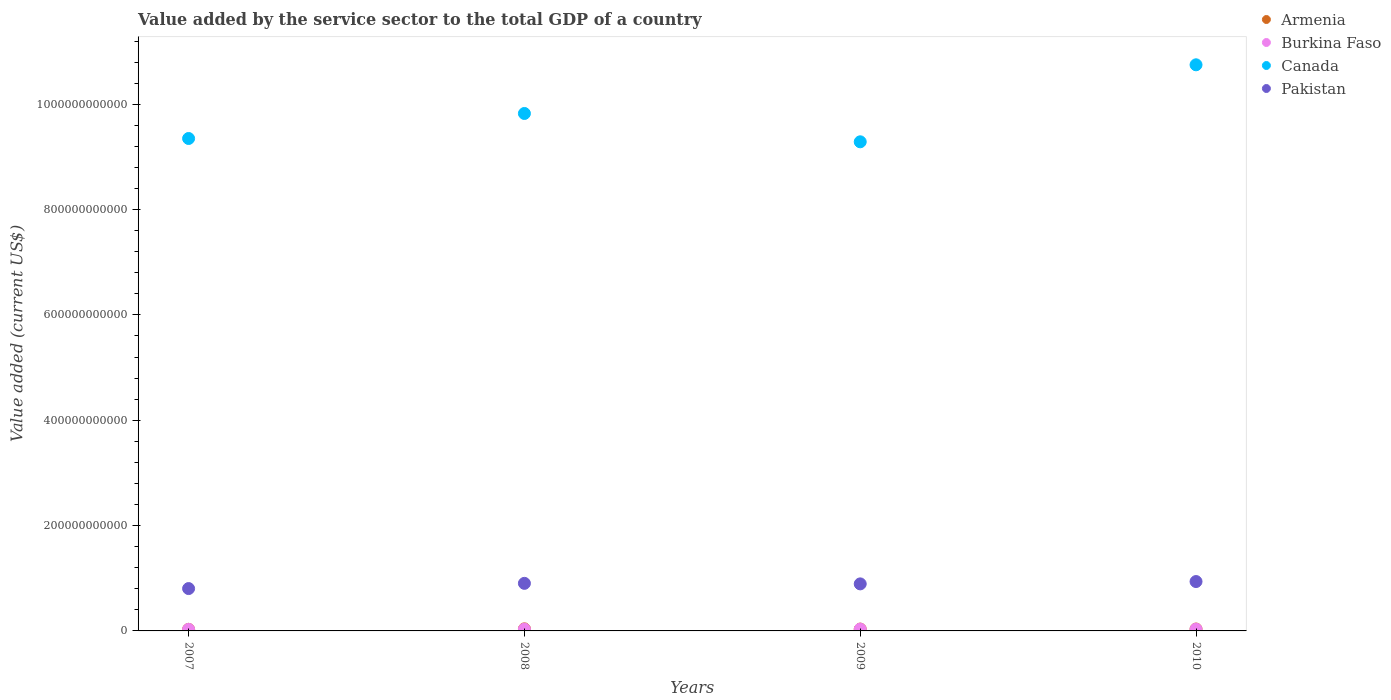How many different coloured dotlines are there?
Offer a terse response. 4. What is the value added by the service sector to the total GDP in Burkina Faso in 2009?
Your answer should be very brief. 3.44e+09. Across all years, what is the maximum value added by the service sector to the total GDP in Canada?
Provide a short and direct response. 1.07e+12. Across all years, what is the minimum value added by the service sector to the total GDP in Canada?
Ensure brevity in your answer.  9.29e+11. In which year was the value added by the service sector to the total GDP in Canada maximum?
Ensure brevity in your answer.  2010. In which year was the value added by the service sector to the total GDP in Canada minimum?
Offer a very short reply. 2009. What is the total value added by the service sector to the total GDP in Burkina Faso in the graph?
Provide a short and direct response. 1.32e+1. What is the difference between the value added by the service sector to the total GDP in Pakistan in 2007 and that in 2010?
Provide a short and direct response. -1.33e+1. What is the difference between the value added by the service sector to the total GDP in Armenia in 2007 and the value added by the service sector to the total GDP in Pakistan in 2010?
Ensure brevity in your answer.  -9.08e+1. What is the average value added by the service sector to the total GDP in Canada per year?
Make the answer very short. 9.80e+11. In the year 2007, what is the difference between the value added by the service sector to the total GDP in Armenia and value added by the service sector to the total GDP in Pakistan?
Offer a very short reply. -7.74e+1. In how many years, is the value added by the service sector to the total GDP in Pakistan greater than 800000000000 US$?
Provide a succinct answer. 0. What is the ratio of the value added by the service sector to the total GDP in Canada in 2007 to that in 2008?
Offer a terse response. 0.95. Is the value added by the service sector to the total GDP in Armenia in 2007 less than that in 2010?
Keep it short and to the point. Yes. What is the difference between the highest and the second highest value added by the service sector to the total GDP in Armenia?
Ensure brevity in your answer.  3.33e+08. What is the difference between the highest and the lowest value added by the service sector to the total GDP in Pakistan?
Provide a short and direct response. 1.33e+1. In how many years, is the value added by the service sector to the total GDP in Armenia greater than the average value added by the service sector to the total GDP in Armenia taken over all years?
Offer a very short reply. 3. Is it the case that in every year, the sum of the value added by the service sector to the total GDP in Burkina Faso and value added by the service sector to the total GDP in Armenia  is greater than the sum of value added by the service sector to the total GDP in Canada and value added by the service sector to the total GDP in Pakistan?
Your response must be concise. No. Is it the case that in every year, the sum of the value added by the service sector to the total GDP in Canada and value added by the service sector to the total GDP in Armenia  is greater than the value added by the service sector to the total GDP in Pakistan?
Keep it short and to the point. Yes. Does the value added by the service sector to the total GDP in Pakistan monotonically increase over the years?
Ensure brevity in your answer.  No. What is the difference between two consecutive major ticks on the Y-axis?
Your answer should be very brief. 2.00e+11. Where does the legend appear in the graph?
Ensure brevity in your answer.  Top right. What is the title of the graph?
Ensure brevity in your answer.  Value added by the service sector to the total GDP of a country. What is the label or title of the X-axis?
Make the answer very short. Years. What is the label or title of the Y-axis?
Give a very brief answer. Value added (current US$). What is the Value added (current US$) in Armenia in 2007?
Your answer should be compact. 2.97e+09. What is the Value added (current US$) in Burkina Faso in 2007?
Offer a very short reply. 3.00e+09. What is the Value added (current US$) of Canada in 2007?
Your answer should be very brief. 9.35e+11. What is the Value added (current US$) in Pakistan in 2007?
Keep it short and to the point. 8.04e+1. What is the Value added (current US$) of Armenia in 2008?
Offer a terse response. 3.93e+09. What is the Value added (current US$) of Burkina Faso in 2008?
Provide a succinct answer. 3.36e+09. What is the Value added (current US$) of Canada in 2008?
Your response must be concise. 9.82e+11. What is the Value added (current US$) of Pakistan in 2008?
Provide a short and direct response. 9.03e+1. What is the Value added (current US$) in Armenia in 2009?
Offer a terse response. 3.50e+09. What is the Value added (current US$) of Burkina Faso in 2009?
Make the answer very short. 3.44e+09. What is the Value added (current US$) of Canada in 2009?
Your response must be concise. 9.29e+11. What is the Value added (current US$) of Pakistan in 2009?
Offer a terse response. 8.93e+1. What is the Value added (current US$) in Armenia in 2010?
Your response must be concise. 3.60e+09. What is the Value added (current US$) of Burkina Faso in 2010?
Provide a short and direct response. 3.39e+09. What is the Value added (current US$) of Canada in 2010?
Give a very brief answer. 1.07e+12. What is the Value added (current US$) of Pakistan in 2010?
Give a very brief answer. 9.37e+1. Across all years, what is the maximum Value added (current US$) in Armenia?
Your answer should be compact. 3.93e+09. Across all years, what is the maximum Value added (current US$) in Burkina Faso?
Provide a short and direct response. 3.44e+09. Across all years, what is the maximum Value added (current US$) of Canada?
Give a very brief answer. 1.07e+12. Across all years, what is the maximum Value added (current US$) of Pakistan?
Offer a terse response. 9.37e+1. Across all years, what is the minimum Value added (current US$) of Armenia?
Offer a terse response. 2.97e+09. Across all years, what is the minimum Value added (current US$) in Burkina Faso?
Give a very brief answer. 3.00e+09. Across all years, what is the minimum Value added (current US$) in Canada?
Your answer should be compact. 9.29e+11. Across all years, what is the minimum Value added (current US$) of Pakistan?
Keep it short and to the point. 8.04e+1. What is the total Value added (current US$) of Armenia in the graph?
Ensure brevity in your answer.  1.40e+1. What is the total Value added (current US$) of Burkina Faso in the graph?
Make the answer very short. 1.32e+1. What is the total Value added (current US$) of Canada in the graph?
Keep it short and to the point. 3.92e+12. What is the total Value added (current US$) of Pakistan in the graph?
Make the answer very short. 3.54e+11. What is the difference between the Value added (current US$) of Armenia in 2007 and that in 2008?
Your answer should be compact. -9.67e+08. What is the difference between the Value added (current US$) of Burkina Faso in 2007 and that in 2008?
Offer a very short reply. -3.55e+08. What is the difference between the Value added (current US$) of Canada in 2007 and that in 2008?
Your answer should be compact. -4.75e+1. What is the difference between the Value added (current US$) in Pakistan in 2007 and that in 2008?
Your answer should be compact. -9.92e+09. What is the difference between the Value added (current US$) in Armenia in 2007 and that in 2009?
Give a very brief answer. -5.35e+08. What is the difference between the Value added (current US$) in Burkina Faso in 2007 and that in 2009?
Make the answer very short. -4.35e+08. What is the difference between the Value added (current US$) of Canada in 2007 and that in 2009?
Keep it short and to the point. 6.28e+09. What is the difference between the Value added (current US$) in Pakistan in 2007 and that in 2009?
Make the answer very short. -8.90e+09. What is the difference between the Value added (current US$) in Armenia in 2007 and that in 2010?
Ensure brevity in your answer.  -6.35e+08. What is the difference between the Value added (current US$) of Burkina Faso in 2007 and that in 2010?
Offer a very short reply. -3.93e+08. What is the difference between the Value added (current US$) in Canada in 2007 and that in 2010?
Your answer should be very brief. -1.40e+11. What is the difference between the Value added (current US$) of Pakistan in 2007 and that in 2010?
Your answer should be compact. -1.33e+1. What is the difference between the Value added (current US$) in Armenia in 2008 and that in 2009?
Make the answer very short. 4.33e+08. What is the difference between the Value added (current US$) of Burkina Faso in 2008 and that in 2009?
Provide a succinct answer. -7.99e+07. What is the difference between the Value added (current US$) in Canada in 2008 and that in 2009?
Make the answer very short. 5.38e+1. What is the difference between the Value added (current US$) in Pakistan in 2008 and that in 2009?
Give a very brief answer. 1.02e+09. What is the difference between the Value added (current US$) in Armenia in 2008 and that in 2010?
Your response must be concise. 3.33e+08. What is the difference between the Value added (current US$) of Burkina Faso in 2008 and that in 2010?
Give a very brief answer. -3.77e+07. What is the difference between the Value added (current US$) of Canada in 2008 and that in 2010?
Provide a succinct answer. -9.24e+1. What is the difference between the Value added (current US$) of Pakistan in 2008 and that in 2010?
Make the answer very short. -3.42e+09. What is the difference between the Value added (current US$) in Armenia in 2009 and that in 2010?
Provide a short and direct response. -9.99e+07. What is the difference between the Value added (current US$) of Burkina Faso in 2009 and that in 2010?
Your response must be concise. 4.22e+07. What is the difference between the Value added (current US$) in Canada in 2009 and that in 2010?
Ensure brevity in your answer.  -1.46e+11. What is the difference between the Value added (current US$) in Pakistan in 2009 and that in 2010?
Give a very brief answer. -4.43e+09. What is the difference between the Value added (current US$) in Armenia in 2007 and the Value added (current US$) in Burkina Faso in 2008?
Offer a very short reply. -3.91e+08. What is the difference between the Value added (current US$) of Armenia in 2007 and the Value added (current US$) of Canada in 2008?
Your response must be concise. -9.79e+11. What is the difference between the Value added (current US$) in Armenia in 2007 and the Value added (current US$) in Pakistan in 2008?
Give a very brief answer. -8.74e+1. What is the difference between the Value added (current US$) in Burkina Faso in 2007 and the Value added (current US$) in Canada in 2008?
Provide a succinct answer. -9.79e+11. What is the difference between the Value added (current US$) of Burkina Faso in 2007 and the Value added (current US$) of Pakistan in 2008?
Your response must be concise. -8.73e+1. What is the difference between the Value added (current US$) in Canada in 2007 and the Value added (current US$) in Pakistan in 2008?
Give a very brief answer. 8.45e+11. What is the difference between the Value added (current US$) of Armenia in 2007 and the Value added (current US$) of Burkina Faso in 2009?
Your response must be concise. -4.71e+08. What is the difference between the Value added (current US$) of Armenia in 2007 and the Value added (current US$) of Canada in 2009?
Your answer should be very brief. -9.26e+11. What is the difference between the Value added (current US$) of Armenia in 2007 and the Value added (current US$) of Pakistan in 2009?
Your answer should be compact. -8.63e+1. What is the difference between the Value added (current US$) in Burkina Faso in 2007 and the Value added (current US$) in Canada in 2009?
Your answer should be compact. -9.26e+11. What is the difference between the Value added (current US$) of Burkina Faso in 2007 and the Value added (current US$) of Pakistan in 2009?
Provide a succinct answer. -8.63e+1. What is the difference between the Value added (current US$) in Canada in 2007 and the Value added (current US$) in Pakistan in 2009?
Your answer should be compact. 8.46e+11. What is the difference between the Value added (current US$) of Armenia in 2007 and the Value added (current US$) of Burkina Faso in 2010?
Offer a very short reply. -4.29e+08. What is the difference between the Value added (current US$) of Armenia in 2007 and the Value added (current US$) of Canada in 2010?
Give a very brief answer. -1.07e+12. What is the difference between the Value added (current US$) of Armenia in 2007 and the Value added (current US$) of Pakistan in 2010?
Your response must be concise. -9.08e+1. What is the difference between the Value added (current US$) of Burkina Faso in 2007 and the Value added (current US$) of Canada in 2010?
Ensure brevity in your answer.  -1.07e+12. What is the difference between the Value added (current US$) of Burkina Faso in 2007 and the Value added (current US$) of Pakistan in 2010?
Ensure brevity in your answer.  -9.07e+1. What is the difference between the Value added (current US$) in Canada in 2007 and the Value added (current US$) in Pakistan in 2010?
Your response must be concise. 8.41e+11. What is the difference between the Value added (current US$) in Armenia in 2008 and the Value added (current US$) in Burkina Faso in 2009?
Offer a terse response. 4.97e+08. What is the difference between the Value added (current US$) of Armenia in 2008 and the Value added (current US$) of Canada in 2009?
Give a very brief answer. -9.25e+11. What is the difference between the Value added (current US$) in Armenia in 2008 and the Value added (current US$) in Pakistan in 2009?
Your answer should be compact. -8.54e+1. What is the difference between the Value added (current US$) of Burkina Faso in 2008 and the Value added (current US$) of Canada in 2009?
Your response must be concise. -9.25e+11. What is the difference between the Value added (current US$) of Burkina Faso in 2008 and the Value added (current US$) of Pakistan in 2009?
Offer a terse response. -8.59e+1. What is the difference between the Value added (current US$) in Canada in 2008 and the Value added (current US$) in Pakistan in 2009?
Offer a very short reply. 8.93e+11. What is the difference between the Value added (current US$) in Armenia in 2008 and the Value added (current US$) in Burkina Faso in 2010?
Your answer should be very brief. 5.39e+08. What is the difference between the Value added (current US$) in Armenia in 2008 and the Value added (current US$) in Canada in 2010?
Make the answer very short. -1.07e+12. What is the difference between the Value added (current US$) in Armenia in 2008 and the Value added (current US$) in Pakistan in 2010?
Give a very brief answer. -8.98e+1. What is the difference between the Value added (current US$) in Burkina Faso in 2008 and the Value added (current US$) in Canada in 2010?
Your answer should be compact. -1.07e+12. What is the difference between the Value added (current US$) in Burkina Faso in 2008 and the Value added (current US$) in Pakistan in 2010?
Your response must be concise. -9.04e+1. What is the difference between the Value added (current US$) in Canada in 2008 and the Value added (current US$) in Pakistan in 2010?
Your answer should be very brief. 8.89e+11. What is the difference between the Value added (current US$) of Armenia in 2009 and the Value added (current US$) of Burkina Faso in 2010?
Make the answer very short. 1.06e+08. What is the difference between the Value added (current US$) of Armenia in 2009 and the Value added (current US$) of Canada in 2010?
Your answer should be very brief. -1.07e+12. What is the difference between the Value added (current US$) of Armenia in 2009 and the Value added (current US$) of Pakistan in 2010?
Provide a succinct answer. -9.02e+1. What is the difference between the Value added (current US$) of Burkina Faso in 2009 and the Value added (current US$) of Canada in 2010?
Offer a very short reply. -1.07e+12. What is the difference between the Value added (current US$) in Burkina Faso in 2009 and the Value added (current US$) in Pakistan in 2010?
Offer a terse response. -9.03e+1. What is the difference between the Value added (current US$) of Canada in 2009 and the Value added (current US$) of Pakistan in 2010?
Make the answer very short. 8.35e+11. What is the average Value added (current US$) of Armenia per year?
Make the answer very short. 3.50e+09. What is the average Value added (current US$) of Burkina Faso per year?
Give a very brief answer. 3.30e+09. What is the average Value added (current US$) of Canada per year?
Your response must be concise. 9.80e+11. What is the average Value added (current US$) in Pakistan per year?
Make the answer very short. 8.84e+1. In the year 2007, what is the difference between the Value added (current US$) of Armenia and Value added (current US$) of Burkina Faso?
Offer a very short reply. -3.54e+07. In the year 2007, what is the difference between the Value added (current US$) in Armenia and Value added (current US$) in Canada?
Keep it short and to the point. -9.32e+11. In the year 2007, what is the difference between the Value added (current US$) of Armenia and Value added (current US$) of Pakistan?
Your answer should be compact. -7.74e+1. In the year 2007, what is the difference between the Value added (current US$) of Burkina Faso and Value added (current US$) of Canada?
Give a very brief answer. -9.32e+11. In the year 2007, what is the difference between the Value added (current US$) in Burkina Faso and Value added (current US$) in Pakistan?
Offer a very short reply. -7.74e+1. In the year 2007, what is the difference between the Value added (current US$) of Canada and Value added (current US$) of Pakistan?
Offer a terse response. 8.55e+11. In the year 2008, what is the difference between the Value added (current US$) in Armenia and Value added (current US$) in Burkina Faso?
Make the answer very short. 5.77e+08. In the year 2008, what is the difference between the Value added (current US$) of Armenia and Value added (current US$) of Canada?
Make the answer very short. -9.78e+11. In the year 2008, what is the difference between the Value added (current US$) of Armenia and Value added (current US$) of Pakistan?
Keep it short and to the point. -8.64e+1. In the year 2008, what is the difference between the Value added (current US$) in Burkina Faso and Value added (current US$) in Canada?
Make the answer very short. -9.79e+11. In the year 2008, what is the difference between the Value added (current US$) in Burkina Faso and Value added (current US$) in Pakistan?
Make the answer very short. -8.70e+1. In the year 2008, what is the difference between the Value added (current US$) in Canada and Value added (current US$) in Pakistan?
Your response must be concise. 8.92e+11. In the year 2009, what is the difference between the Value added (current US$) of Armenia and Value added (current US$) of Burkina Faso?
Provide a short and direct response. 6.42e+07. In the year 2009, what is the difference between the Value added (current US$) in Armenia and Value added (current US$) in Canada?
Make the answer very short. -9.25e+11. In the year 2009, what is the difference between the Value added (current US$) of Armenia and Value added (current US$) of Pakistan?
Your answer should be very brief. -8.58e+1. In the year 2009, what is the difference between the Value added (current US$) of Burkina Faso and Value added (current US$) of Canada?
Offer a terse response. -9.25e+11. In the year 2009, what is the difference between the Value added (current US$) of Burkina Faso and Value added (current US$) of Pakistan?
Give a very brief answer. -8.59e+1. In the year 2009, what is the difference between the Value added (current US$) of Canada and Value added (current US$) of Pakistan?
Your response must be concise. 8.39e+11. In the year 2010, what is the difference between the Value added (current US$) of Armenia and Value added (current US$) of Burkina Faso?
Offer a terse response. 2.06e+08. In the year 2010, what is the difference between the Value added (current US$) in Armenia and Value added (current US$) in Canada?
Offer a very short reply. -1.07e+12. In the year 2010, what is the difference between the Value added (current US$) in Armenia and Value added (current US$) in Pakistan?
Your answer should be very brief. -9.01e+1. In the year 2010, what is the difference between the Value added (current US$) of Burkina Faso and Value added (current US$) of Canada?
Provide a short and direct response. -1.07e+12. In the year 2010, what is the difference between the Value added (current US$) in Burkina Faso and Value added (current US$) in Pakistan?
Offer a terse response. -9.03e+1. In the year 2010, what is the difference between the Value added (current US$) in Canada and Value added (current US$) in Pakistan?
Provide a short and direct response. 9.81e+11. What is the ratio of the Value added (current US$) of Armenia in 2007 to that in 2008?
Give a very brief answer. 0.75. What is the ratio of the Value added (current US$) of Burkina Faso in 2007 to that in 2008?
Provide a short and direct response. 0.89. What is the ratio of the Value added (current US$) in Canada in 2007 to that in 2008?
Make the answer very short. 0.95. What is the ratio of the Value added (current US$) of Pakistan in 2007 to that in 2008?
Your response must be concise. 0.89. What is the ratio of the Value added (current US$) in Armenia in 2007 to that in 2009?
Your response must be concise. 0.85. What is the ratio of the Value added (current US$) of Burkina Faso in 2007 to that in 2009?
Make the answer very short. 0.87. What is the ratio of the Value added (current US$) of Canada in 2007 to that in 2009?
Provide a succinct answer. 1.01. What is the ratio of the Value added (current US$) in Pakistan in 2007 to that in 2009?
Offer a terse response. 0.9. What is the ratio of the Value added (current US$) of Armenia in 2007 to that in 2010?
Your answer should be very brief. 0.82. What is the ratio of the Value added (current US$) of Burkina Faso in 2007 to that in 2010?
Keep it short and to the point. 0.88. What is the ratio of the Value added (current US$) in Canada in 2007 to that in 2010?
Give a very brief answer. 0.87. What is the ratio of the Value added (current US$) of Pakistan in 2007 to that in 2010?
Offer a terse response. 0.86. What is the ratio of the Value added (current US$) of Armenia in 2008 to that in 2009?
Ensure brevity in your answer.  1.12. What is the ratio of the Value added (current US$) in Burkina Faso in 2008 to that in 2009?
Offer a very short reply. 0.98. What is the ratio of the Value added (current US$) of Canada in 2008 to that in 2009?
Your answer should be very brief. 1.06. What is the ratio of the Value added (current US$) in Pakistan in 2008 to that in 2009?
Provide a short and direct response. 1.01. What is the ratio of the Value added (current US$) in Armenia in 2008 to that in 2010?
Give a very brief answer. 1.09. What is the ratio of the Value added (current US$) of Burkina Faso in 2008 to that in 2010?
Your answer should be very brief. 0.99. What is the ratio of the Value added (current US$) in Canada in 2008 to that in 2010?
Your answer should be very brief. 0.91. What is the ratio of the Value added (current US$) in Pakistan in 2008 to that in 2010?
Your answer should be compact. 0.96. What is the ratio of the Value added (current US$) in Armenia in 2009 to that in 2010?
Keep it short and to the point. 0.97. What is the ratio of the Value added (current US$) of Burkina Faso in 2009 to that in 2010?
Provide a succinct answer. 1.01. What is the ratio of the Value added (current US$) of Canada in 2009 to that in 2010?
Your answer should be very brief. 0.86. What is the ratio of the Value added (current US$) in Pakistan in 2009 to that in 2010?
Your response must be concise. 0.95. What is the difference between the highest and the second highest Value added (current US$) in Armenia?
Make the answer very short. 3.33e+08. What is the difference between the highest and the second highest Value added (current US$) of Burkina Faso?
Give a very brief answer. 4.22e+07. What is the difference between the highest and the second highest Value added (current US$) of Canada?
Offer a very short reply. 9.24e+1. What is the difference between the highest and the second highest Value added (current US$) of Pakistan?
Make the answer very short. 3.42e+09. What is the difference between the highest and the lowest Value added (current US$) in Armenia?
Offer a terse response. 9.67e+08. What is the difference between the highest and the lowest Value added (current US$) of Burkina Faso?
Your answer should be very brief. 4.35e+08. What is the difference between the highest and the lowest Value added (current US$) of Canada?
Your response must be concise. 1.46e+11. What is the difference between the highest and the lowest Value added (current US$) of Pakistan?
Make the answer very short. 1.33e+1. 